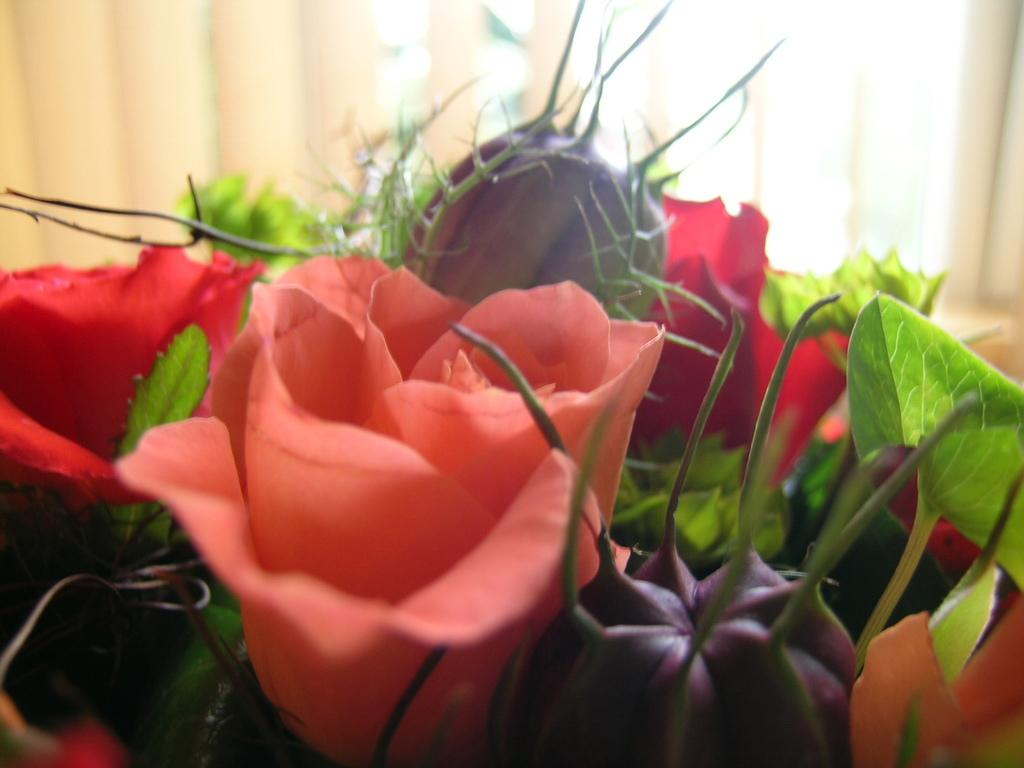What color is the rose in the image? The rose in the image is peach-colored. What type of plant is featured in the image? There are flowers in the image, including a peach-colored rose. What type of structure can be seen in the background of the image? There is no structure visible in the background of the image; it only features flowers. What country is the image taken in? The image does not provide any information about the country in which it was taken. 